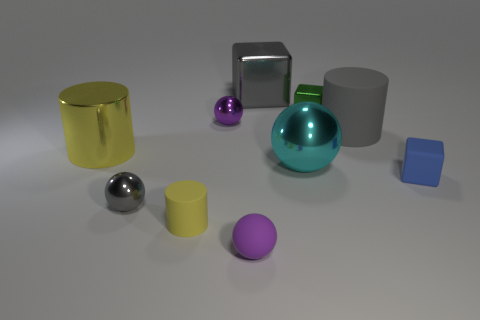Are the shapes in any particular arrangement or pattern? The shapes do not conform to any recognizable pattern or arrangement. They are dispersed across the surface in a non-uniform manner, which suggests a random placement rather than a deliberate pattern. 